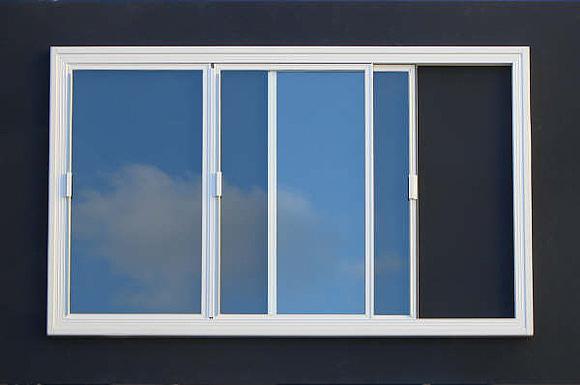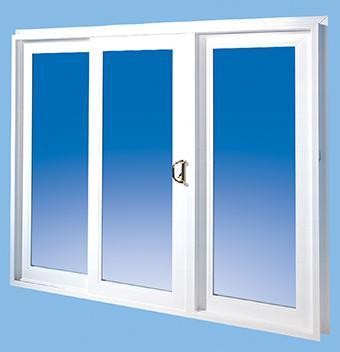The first image is the image on the left, the second image is the image on the right. Assess this claim about the two images: "In the image to the right, the window's handle is black, and large enough for a solid grip.". Correct or not? Answer yes or no. Yes. 